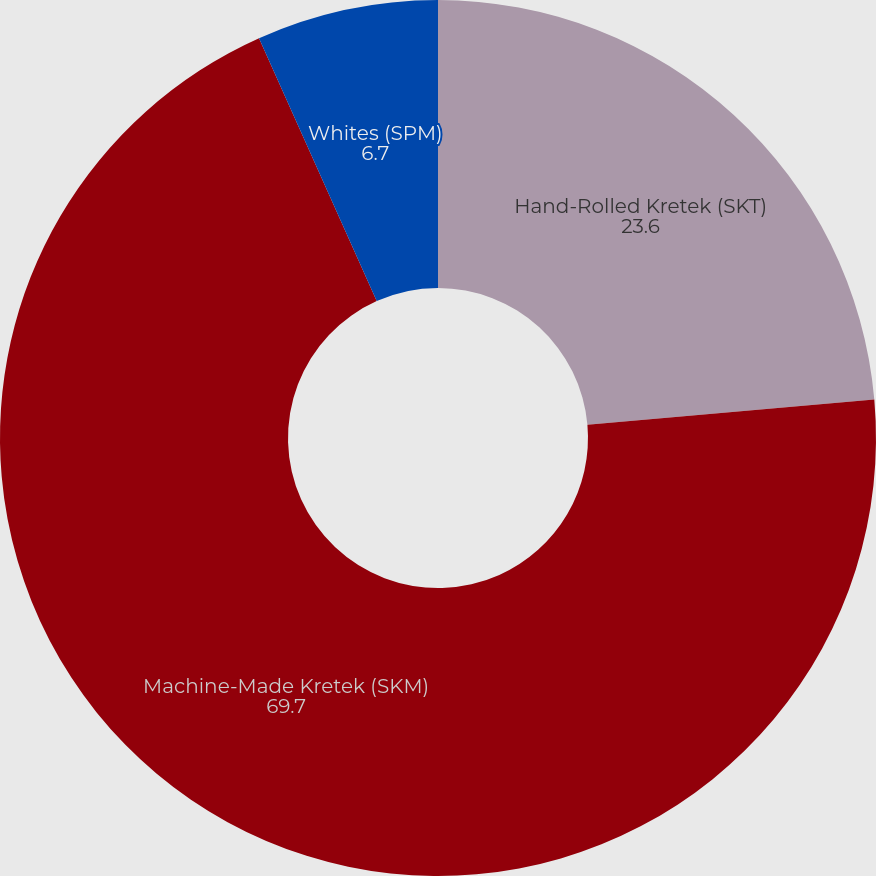Convert chart to OTSL. <chart><loc_0><loc_0><loc_500><loc_500><pie_chart><fcel>Hand-Rolled Kretek (SKT)<fcel>Machine-Made Kretek (SKM)<fcel>Whites (SPM)<nl><fcel>23.6%<fcel>69.7%<fcel>6.7%<nl></chart> 